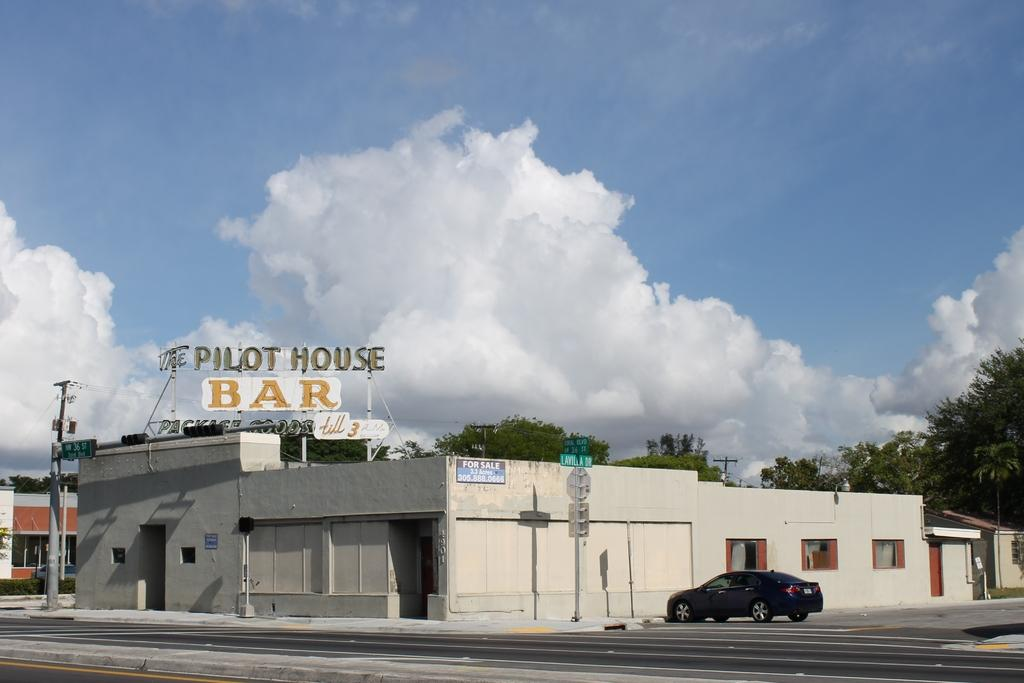What type of structures can be seen in the image? There are houses in the image. Can you describe any specific details about one of the houses? One house has text on it. What else can be seen in the image besides the houses? There is a poster with text, a road, a vehicle, poles, lights, boards, trees, and the sky with clouds are visible in the image. How many beds can be seen in the image? There are no beds present in the image. What direction is the vehicle moving in the image? The image does not show the vehicle in motion, so it is not possible to determine the direction it is moving. 